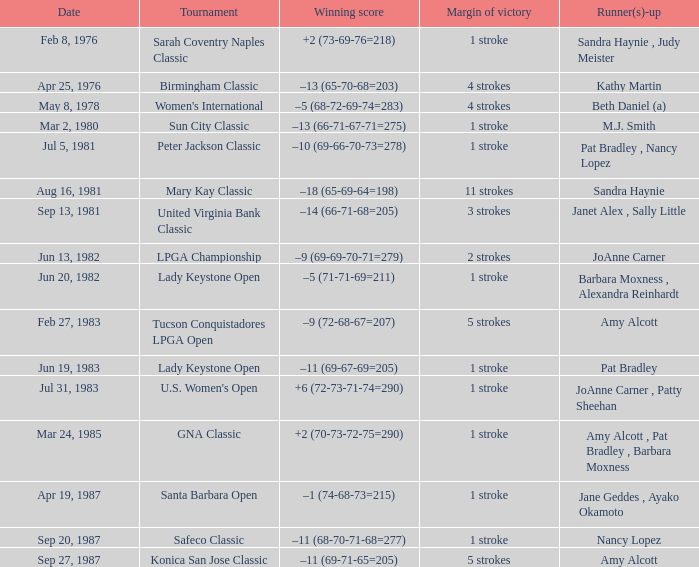In which tournament does the winning score result in -9 (69-69-70-71=279)? LPGA Championship. 